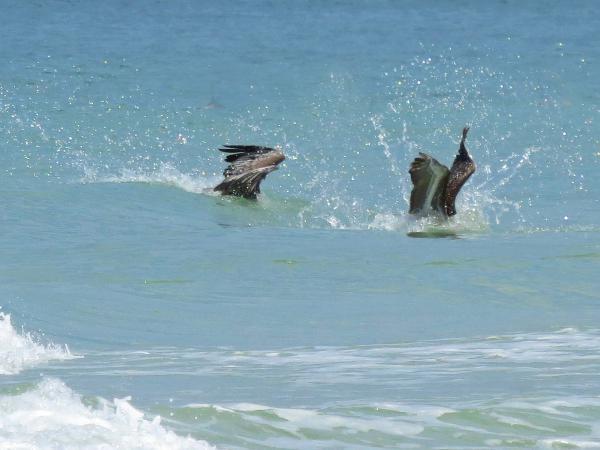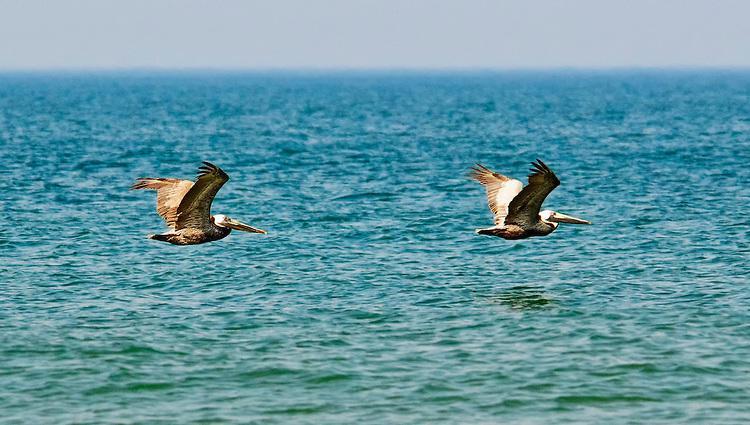The first image is the image on the left, the second image is the image on the right. Analyze the images presented: Is the assertion "One image shows two pelicans in flight above the water, and the other image shows two pelicans that have plunged into the water." valid? Answer yes or no. Yes. The first image is the image on the left, the second image is the image on the right. Given the left and right images, does the statement "At least one pelican is diving for food with its head in the water." hold true? Answer yes or no. Yes. 